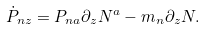Convert formula to latex. <formula><loc_0><loc_0><loc_500><loc_500>\dot { P } _ { n z } = P _ { n a } \partial _ { z } N ^ { a } - m _ { n } \partial _ { z } N .</formula> 